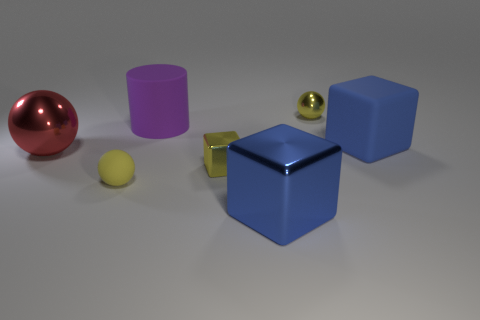Add 3 blue blocks. How many objects exist? 10 Subtract all balls. How many objects are left? 4 Subtract all big metal blocks. Subtract all small brown shiny cylinders. How many objects are left? 6 Add 4 big blue metal things. How many big blue metal things are left? 5 Add 5 purple matte cylinders. How many purple matte cylinders exist? 6 Subtract 0 green spheres. How many objects are left? 7 